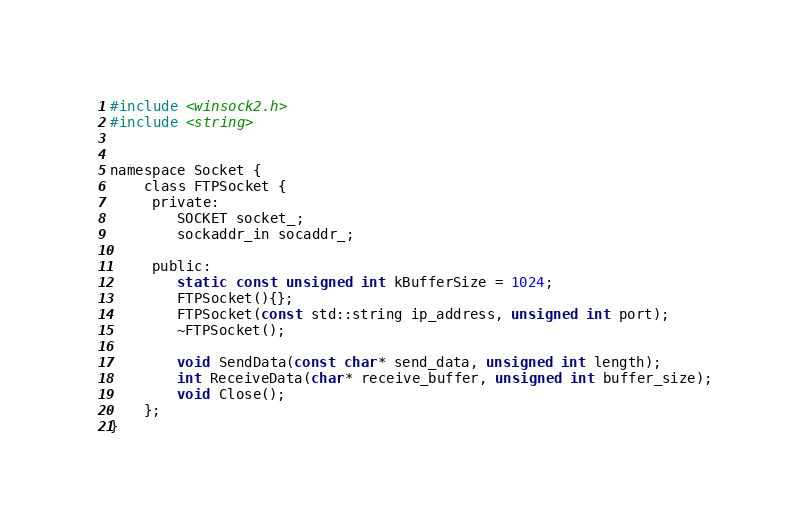<code> <loc_0><loc_0><loc_500><loc_500><_C_>
#include <winsock2.h>
#include <string>


namespace Socket {
	class FTPSocket {
	 private:
		SOCKET socket_;
		sockaddr_in socaddr_;

	 public:
		static const unsigned int kBufferSize = 1024;
		FTPSocket(){};
		FTPSocket(const std::string ip_address, unsigned int port);
		~FTPSocket();

		void SendData(const char* send_data, unsigned int length);
		int ReceiveData(char* receive_buffer, unsigned int buffer_size);
		void Close();
	};
}
</code> 